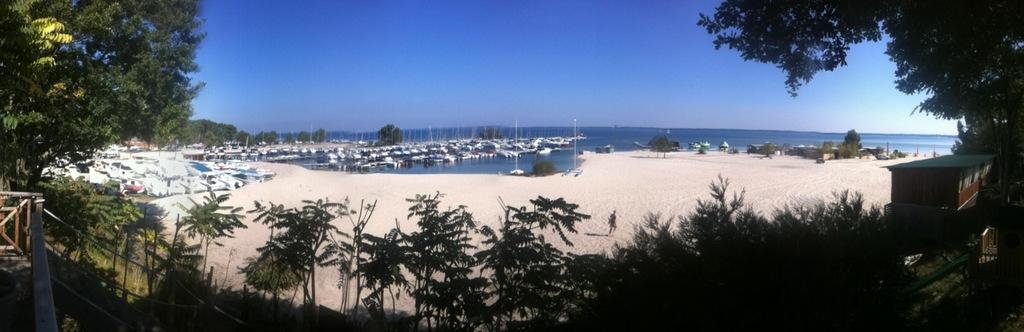What can be seen on the side of the beach in the image? There are many boats on the side of the beach in the image. What is located in the front of the image? There are many trees in the front of the image. What is visible in the back of the image? The ocean is visible in the back of the image. What is visible above the image? The sky is visible above the image. What type of agreement is being discussed by the representative and the trains in the image? There are no representatives or trains present in the image; it features boats, trees, the ocean, and the sky. 